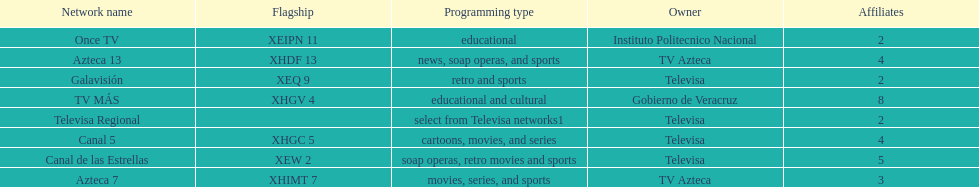How many networks show soap operas? 2. 